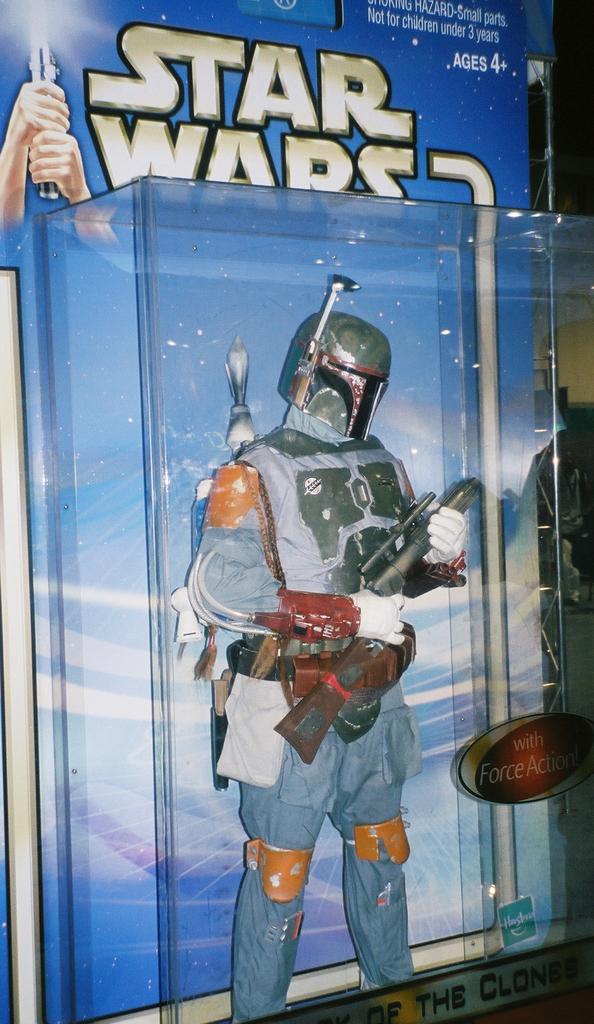What movie franchise is this?
Keep it short and to the point. Star wars. Does he have force action?
Your response must be concise. Yes. 